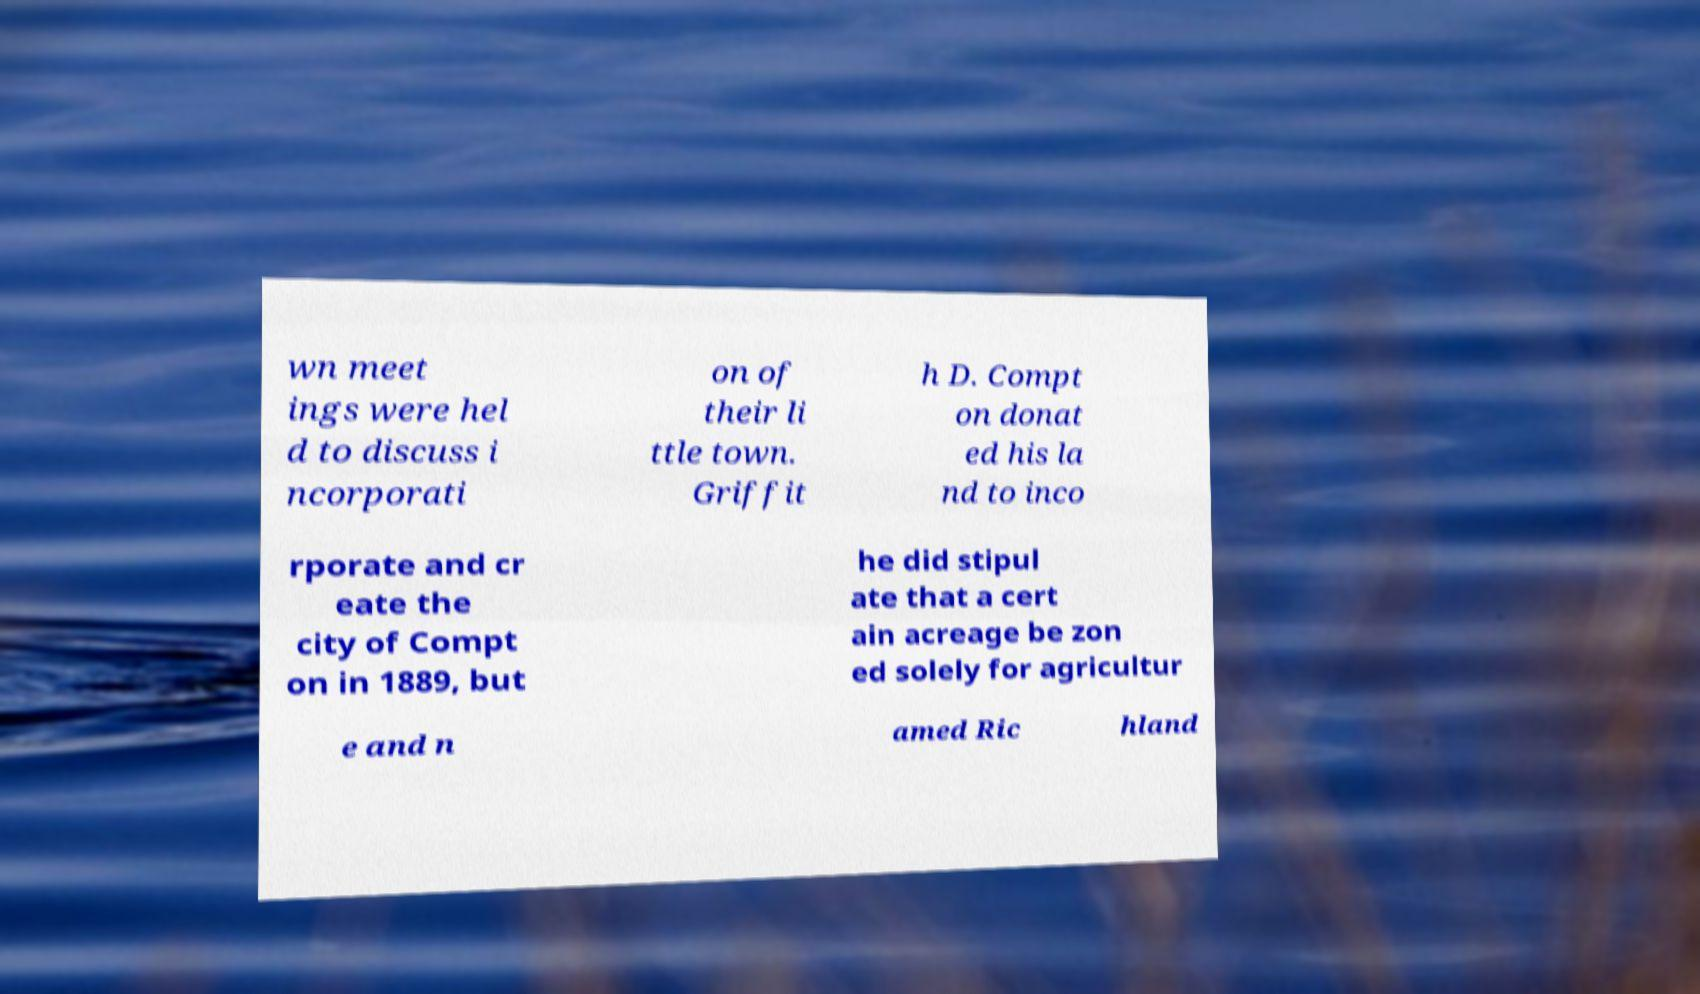For documentation purposes, I need the text within this image transcribed. Could you provide that? wn meet ings were hel d to discuss i ncorporati on of their li ttle town. Griffit h D. Compt on donat ed his la nd to inco rporate and cr eate the city of Compt on in 1889, but he did stipul ate that a cert ain acreage be zon ed solely for agricultur e and n amed Ric hland 